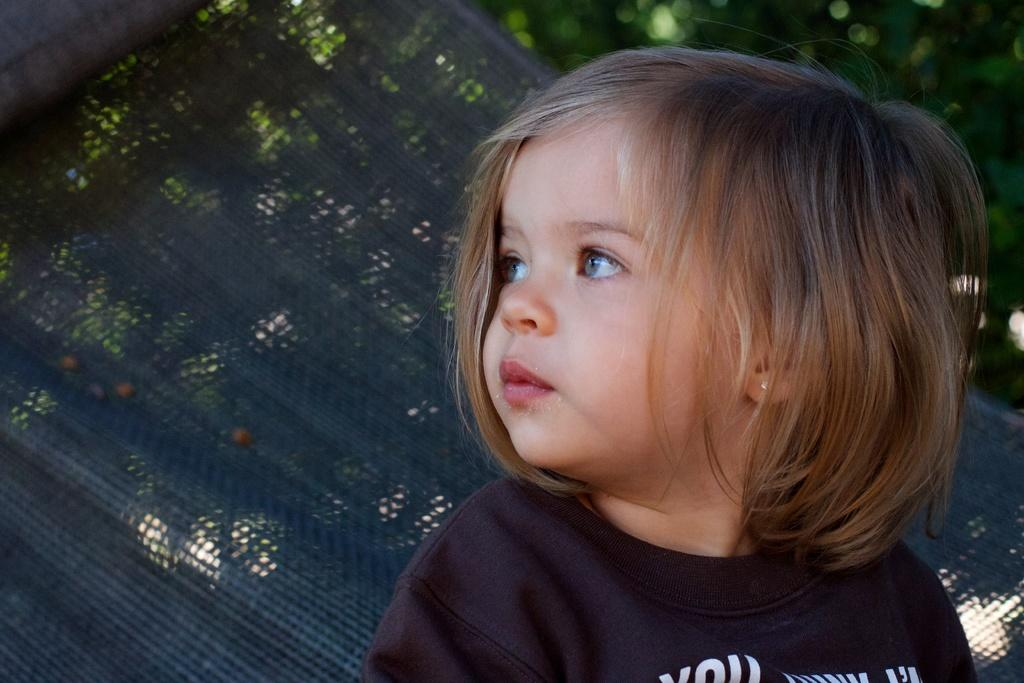What is the main subject of the image? There is a child in the image. What is the child wearing? The child is wearing a black t-shirt. What is the child doing in the image? The child is sitting on a hanging swing. How would you describe the background of the image? The background of the image is slightly blurred. What can be seen in the distance in the image? Trees are visible in the background of the image. What rate does the creator of the swing use to care for the child in the image? There is no information about the creator of the swing or their care for the child in the image. 